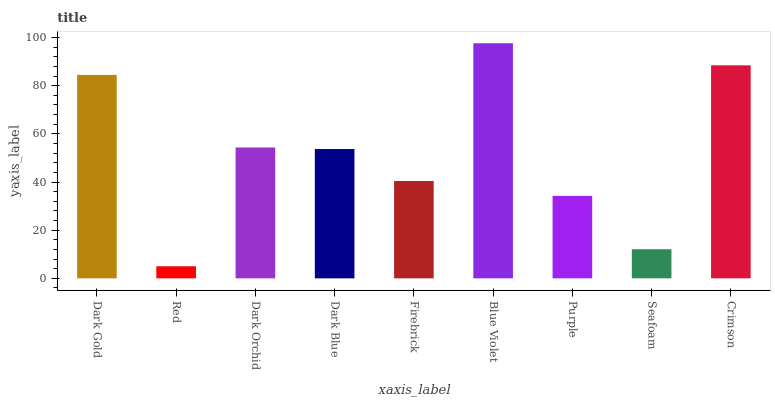Is Red the minimum?
Answer yes or no. Yes. Is Blue Violet the maximum?
Answer yes or no. Yes. Is Dark Orchid the minimum?
Answer yes or no. No. Is Dark Orchid the maximum?
Answer yes or no. No. Is Dark Orchid greater than Red?
Answer yes or no. Yes. Is Red less than Dark Orchid?
Answer yes or no. Yes. Is Red greater than Dark Orchid?
Answer yes or no. No. Is Dark Orchid less than Red?
Answer yes or no. No. Is Dark Blue the high median?
Answer yes or no. Yes. Is Dark Blue the low median?
Answer yes or no. Yes. Is Purple the high median?
Answer yes or no. No. Is Firebrick the low median?
Answer yes or no. No. 